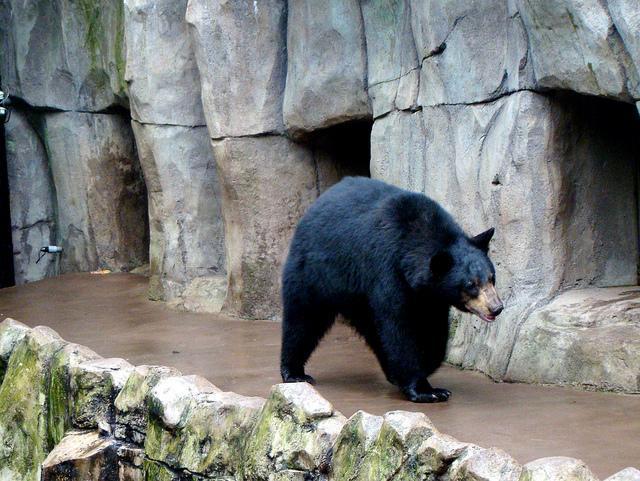How many people are wearing a red hat?
Give a very brief answer. 0. 